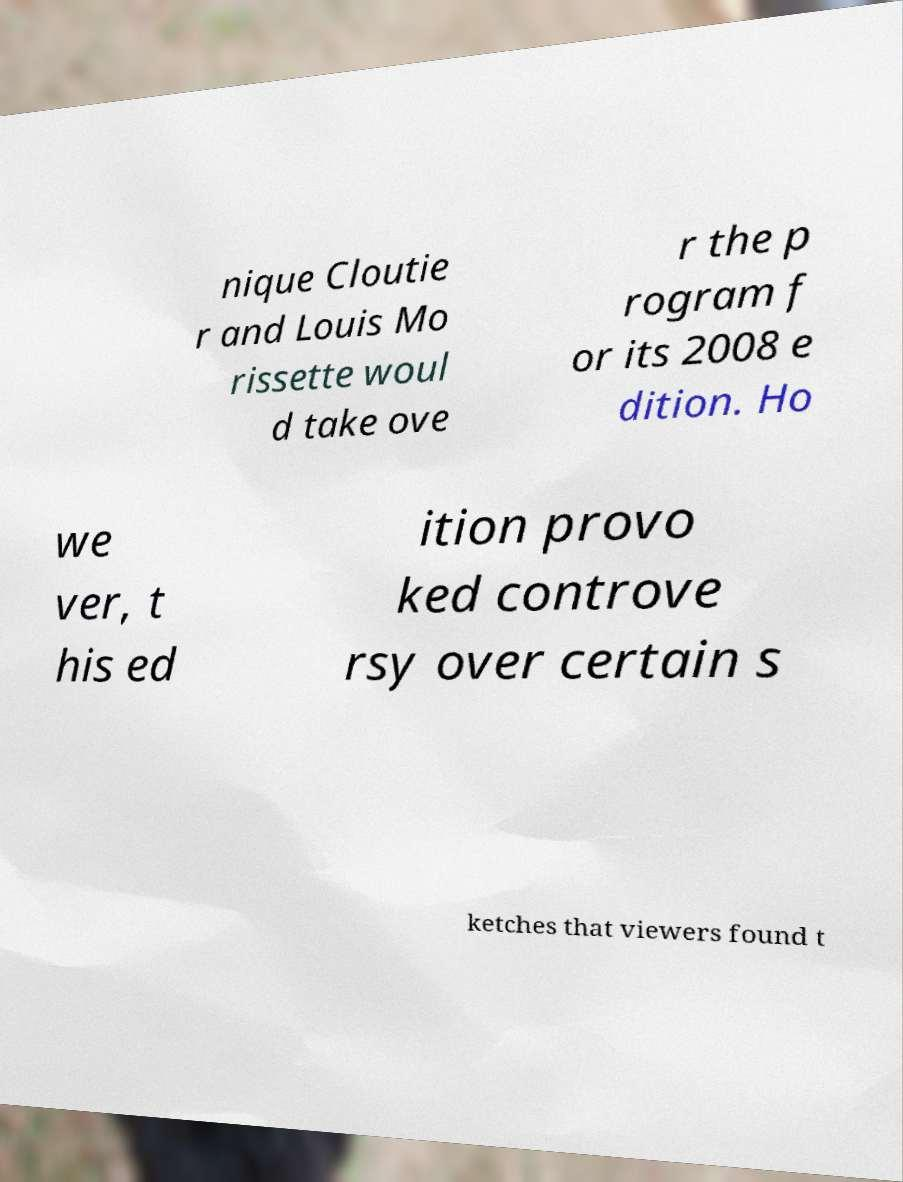Can you accurately transcribe the text from the provided image for me? nique Cloutie r and Louis Mo rissette woul d take ove r the p rogram f or its 2008 e dition. Ho we ver, t his ed ition provo ked controve rsy over certain s ketches that viewers found t 